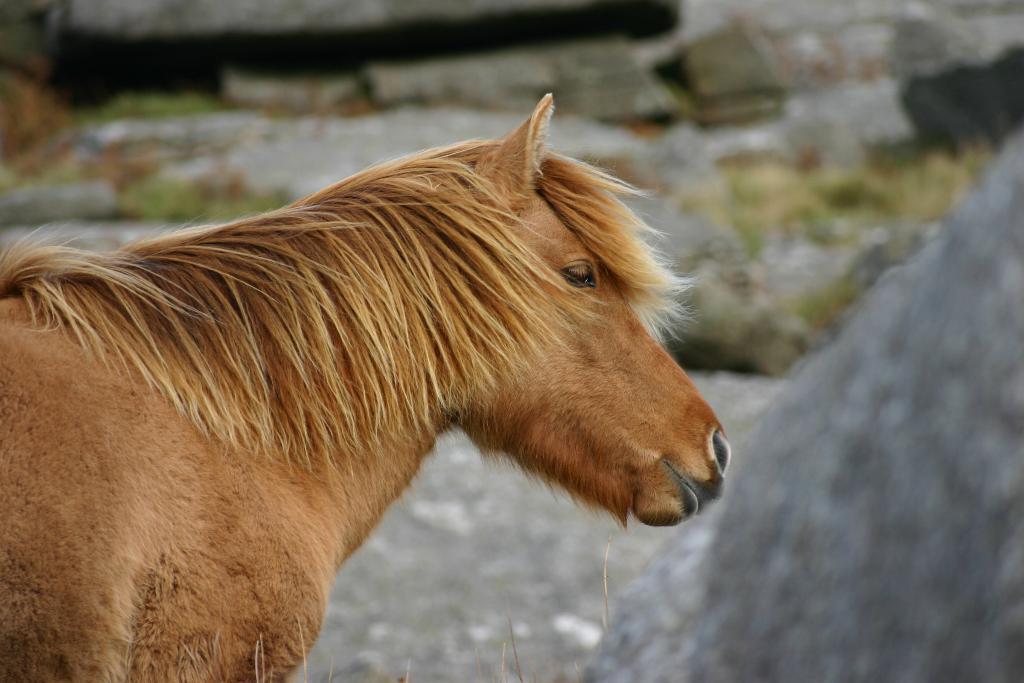Please provide a concise description of this image. In this picture we can see a horse in the front, there is a blurry background. 